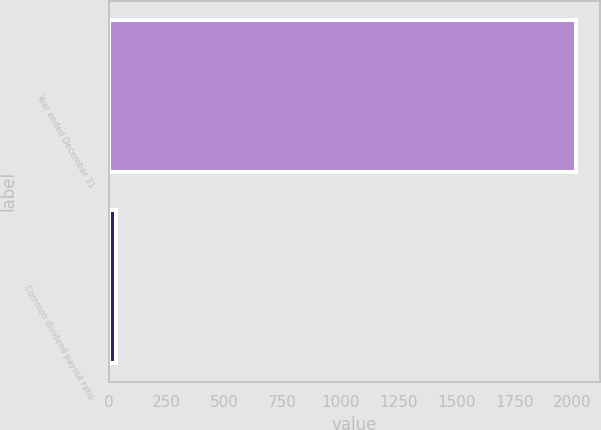<chart> <loc_0><loc_0><loc_500><loc_500><bar_chart><fcel>Year ended December 31<fcel>Common dividend payout ratio<nl><fcel>2017<fcel>33<nl></chart> 